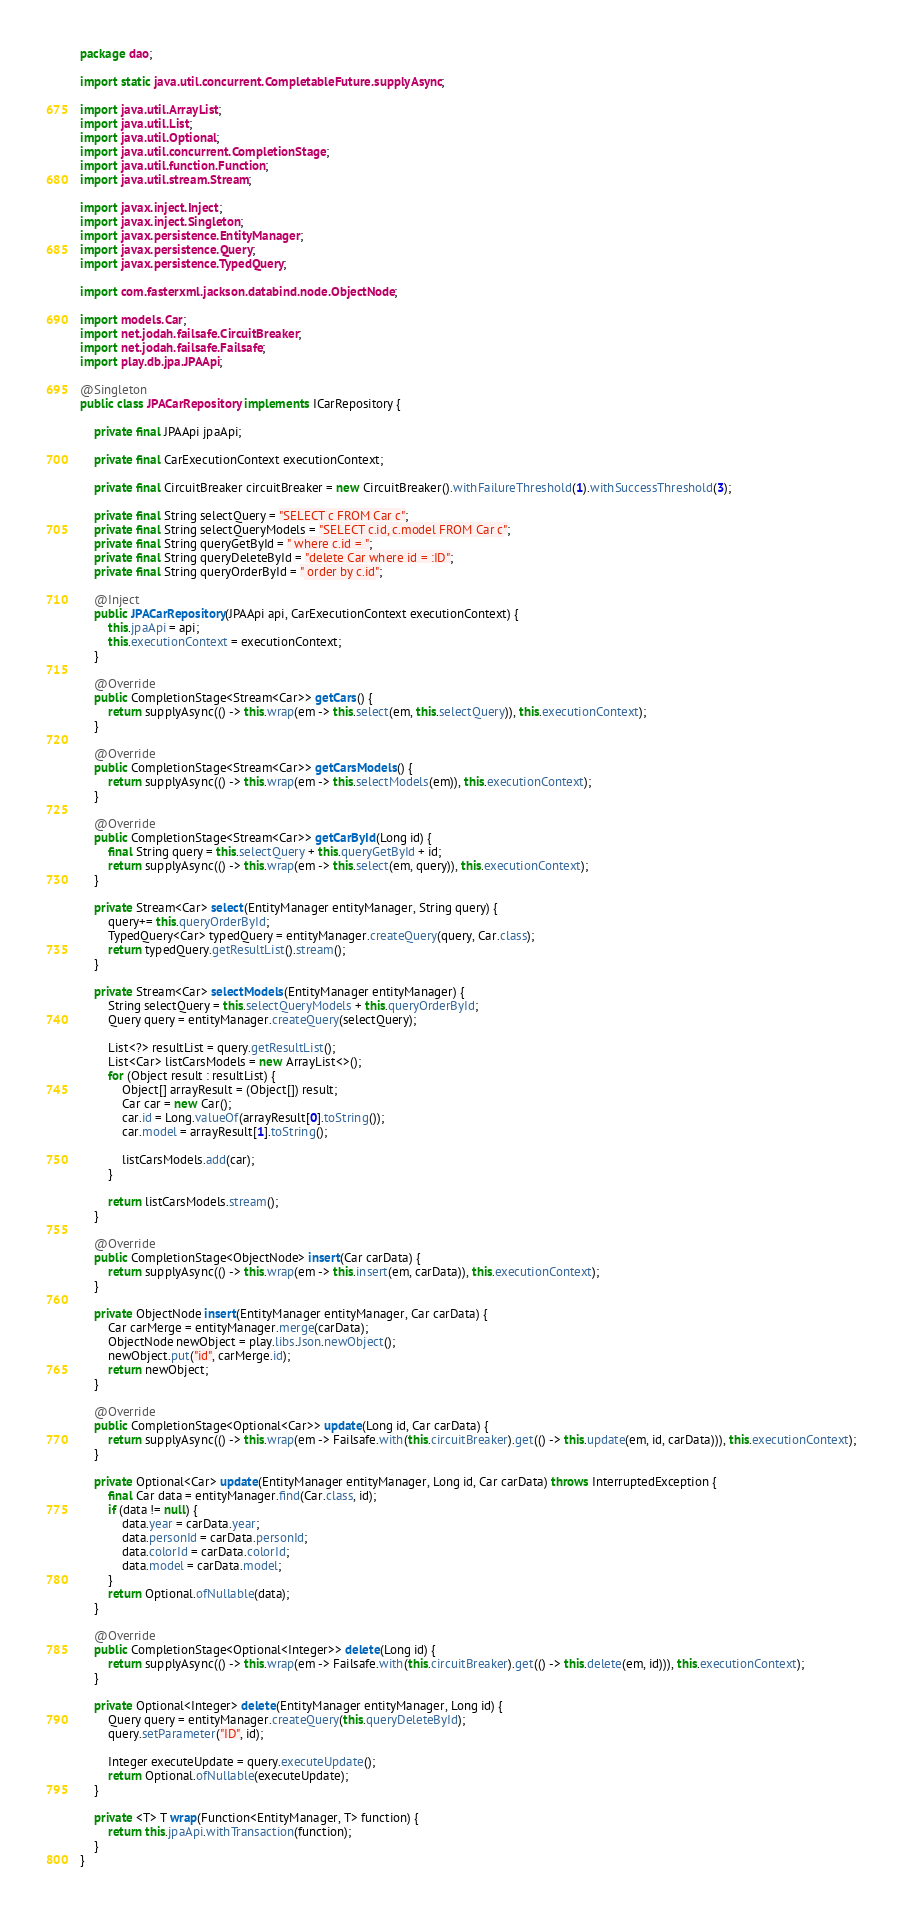<code> <loc_0><loc_0><loc_500><loc_500><_Java_>package dao;

import static java.util.concurrent.CompletableFuture.supplyAsync;

import java.util.ArrayList;
import java.util.List;
import java.util.Optional;
import java.util.concurrent.CompletionStage;
import java.util.function.Function;
import java.util.stream.Stream;

import javax.inject.Inject;
import javax.inject.Singleton;
import javax.persistence.EntityManager;
import javax.persistence.Query;
import javax.persistence.TypedQuery;

import com.fasterxml.jackson.databind.node.ObjectNode;

import models.Car;
import net.jodah.failsafe.CircuitBreaker;
import net.jodah.failsafe.Failsafe;
import play.db.jpa.JPAApi;

@Singleton
public class JPACarRepository implements ICarRepository {

    private final JPAApi jpaApi;
    
    private final CarExecutionContext executionContext;
    
    private final CircuitBreaker circuitBreaker = new CircuitBreaker().withFailureThreshold(1).withSuccessThreshold(3);
    
    private final String selectQuery = "SELECT c FROM Car c";
    private final String selectQueryModels = "SELECT c.id, c.model FROM Car c";
    private final String queryGetById = " where c.id = ";
    private final String queryDeleteById = "delete Car where id = :ID";
    private final String queryOrderById = " order by c.id";

    @Inject
    public JPACarRepository(JPAApi api, CarExecutionContext executionContext) {
        this.jpaApi = api;
        this.executionContext = executionContext;
    }

    @Override
    public CompletionStage<Stream<Car>> getCars() {
        return supplyAsync(() -> this.wrap(em -> this.select(em, this.selectQuery)), this.executionContext);
    }
    
    @Override
    public CompletionStage<Stream<Car>> getCarsModels() {
        return supplyAsync(() -> this.wrap(em -> this.selectModels(em)), this.executionContext);
    }
    
    @Override
	public CompletionStage<Stream<Car>> getCarById(Long id) {
    	final String query = this.selectQuery + this.queryGetById + id;
    	return supplyAsync(() -> this.wrap(em -> this.select(em, query)), this.executionContext);
	}
    
    private Stream<Car> select(EntityManager entityManager, String query) {
    	query+= this.queryOrderById;
    	TypedQuery<Car> typedQuery = entityManager.createQuery(query, Car.class);
        return typedQuery.getResultList().stream();
    }
    
    private Stream<Car> selectModels(EntityManager entityManager) {
    	String selectQuery = this.selectQueryModels + this.queryOrderById;
    	Query query = entityManager.createQuery(selectQuery);
    	
    	List<?> resultList = query.getResultList();
    	List<Car> listCarsModels = new ArrayList<>();
    	for (Object result : resultList) {
    		Object[] arrayResult = (Object[]) result;
    		Car car = new Car();
    		car.id = Long.valueOf(arrayResult[0].toString());
    		car.model = arrayResult[1].toString();
    		
			listCarsModels.add(car);
		}
    	
    	return listCarsModels.stream();
    }
    
    @Override
    public CompletionStage<ObjectNode> insert(Car carData) {
        return supplyAsync(() -> this.wrap(em -> this.insert(em, carData)), this.executionContext);
    }
    
    private ObjectNode insert(EntityManager entityManager, Car carData) {
    	Car carMerge = entityManager.merge(carData);
		ObjectNode newObject = play.libs.Json.newObject();
		newObject.put("id", carMerge.id);
        return newObject;
    }

    @Override
    public CompletionStage<Optional<Car>> update(Long id, Car carData) {
        return supplyAsync(() -> this.wrap(em -> Failsafe.with(this.circuitBreaker).get(() -> this.update(em, id, carData))), this.executionContext);
    }
    
    private Optional<Car> update(EntityManager entityManager, Long id, Car carData) throws InterruptedException {
        final Car data = entityManager.find(Car.class, id);
        if (data != null) {
        	data.year = carData.year;
        	data.personId = carData.personId;
        	data.colorId = carData.colorId;
        	data.model = carData.model;
        }
        return Optional.ofNullable(data);
    }
    
    @Override
    public CompletionStage<Optional<Integer>> delete(Long id) {
        return supplyAsync(() -> this.wrap(em -> Failsafe.with(this.circuitBreaker).get(() -> this.delete(em, id))), this.executionContext);
    }
    
    private Optional<Integer> delete(EntityManager entityManager, Long id) {
    	Query query = entityManager.createQuery(this.queryDeleteById);
    	query.setParameter("ID", id);
    	
    	Integer executeUpdate = query.executeUpdate();
    	return Optional.ofNullable(executeUpdate);
    }
    
    private <T> T wrap(Function<EntityManager, T> function) {
        return this.jpaApi.withTransaction(function);
    }
}</code> 